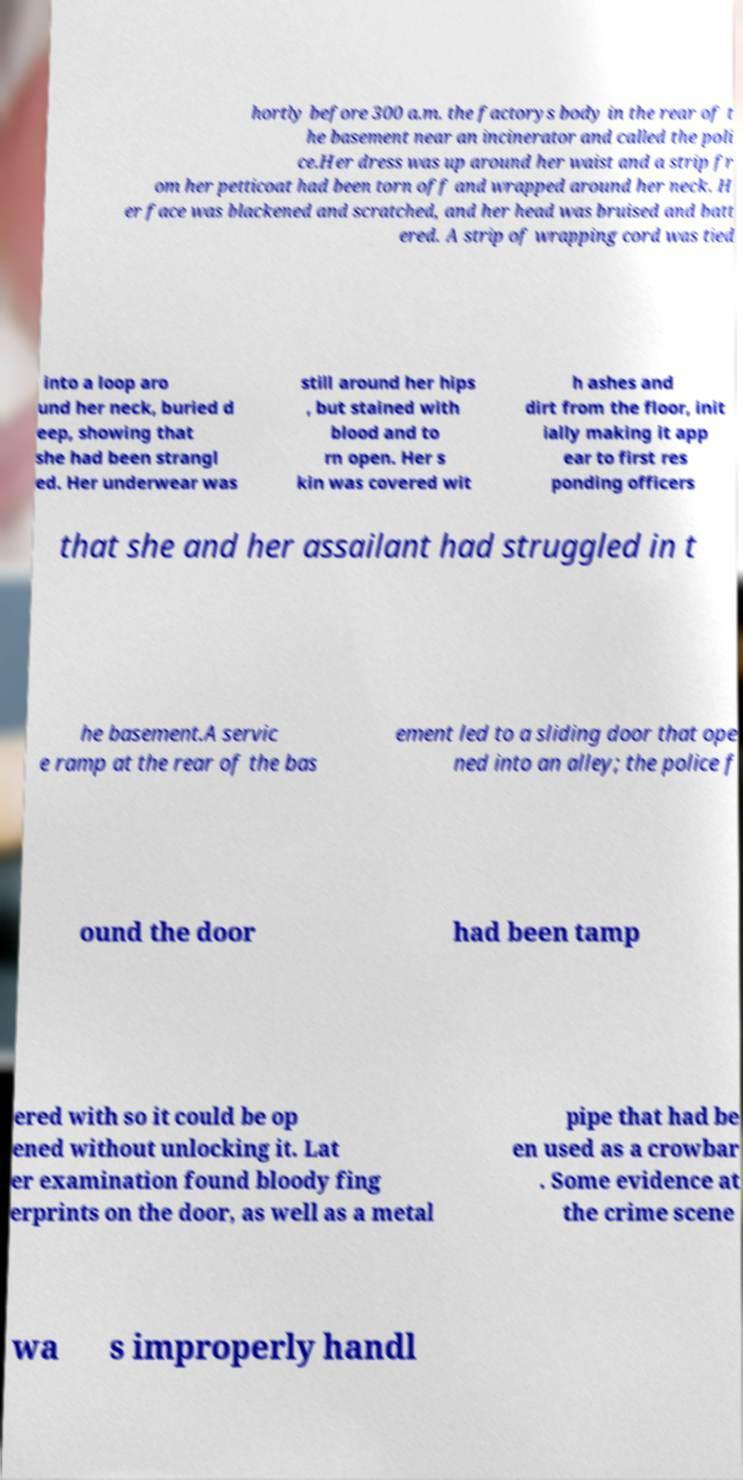For documentation purposes, I need the text within this image transcribed. Could you provide that? hortly before 300 a.m. the factorys body in the rear of t he basement near an incinerator and called the poli ce.Her dress was up around her waist and a strip fr om her petticoat had been torn off and wrapped around her neck. H er face was blackened and scratched, and her head was bruised and batt ered. A strip of wrapping cord was tied into a loop aro und her neck, buried d eep, showing that she had been strangl ed. Her underwear was still around her hips , but stained with blood and to rn open. Her s kin was covered wit h ashes and dirt from the floor, init ially making it app ear to first res ponding officers that she and her assailant had struggled in t he basement.A servic e ramp at the rear of the bas ement led to a sliding door that ope ned into an alley; the police f ound the door had been tamp ered with so it could be op ened without unlocking it. Lat er examination found bloody fing erprints on the door, as well as a metal pipe that had be en used as a crowbar . Some evidence at the crime scene wa s improperly handl 